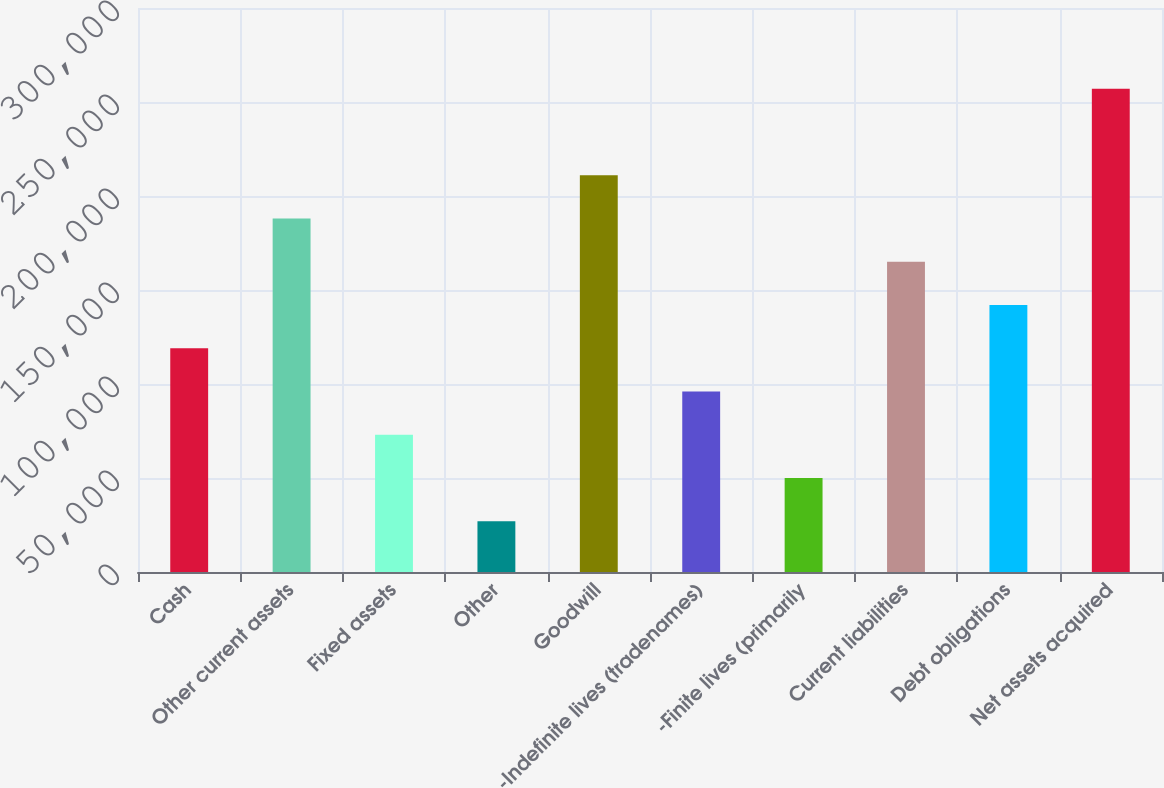Convert chart. <chart><loc_0><loc_0><loc_500><loc_500><bar_chart><fcel>Cash<fcel>Other current assets<fcel>Fixed assets<fcel>Other<fcel>Goodwill<fcel>-Indefinite lives (tradenames)<fcel>-Finite lives (primarily<fcel>Current liabilities<fcel>Debt obligations<fcel>Net assets acquired<nl><fcel>119000<fcel>188000<fcel>73000<fcel>27000<fcel>211000<fcel>96000<fcel>50000<fcel>165000<fcel>142000<fcel>257000<nl></chart> 